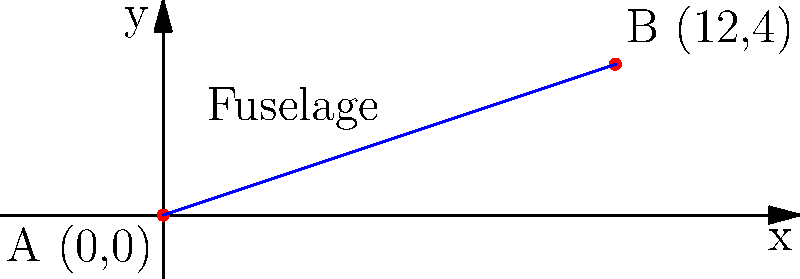A vintage aircraft restoration project requires determining the length of a plane's fuselage. The nose of the plane is represented by point A at (0,0) and the tail by point B at (12,4) on a coordinate system where each unit represents 1 meter. What is the length of the fuselage to the nearest tenth of a meter? To find the length of the fuselage, we need to calculate the distance between points A and B. We can use the distance formula derived from the Pythagorean theorem:

$$d = \sqrt{(x_2 - x_1)^2 + (y_2 - y_1)^2}$$

Where $(x_1, y_1)$ are the coordinates of point A and $(x_2, y_2)$ are the coordinates of point B.

Step 1: Identify the coordinates
A: $(x_1, y_1) = (0, 0)$
B: $(x_2, y_2) = (12, 4)$

Step 2: Plug the values into the distance formula
$$d = \sqrt{(12 - 0)^2 + (4 - 0)^2}$$

Step 3: Simplify
$$d = \sqrt{12^2 + 4^2}$$
$$d = \sqrt{144 + 16}$$
$$d = \sqrt{160}$$

Step 4: Calculate the square root
$$d \approx 12.6491...$$

Step 5: Round to the nearest tenth
$$d \approx 12.6 \text{ meters}$$

Therefore, the length of the fuselage is approximately 12.6 meters.
Answer: 12.6 meters 